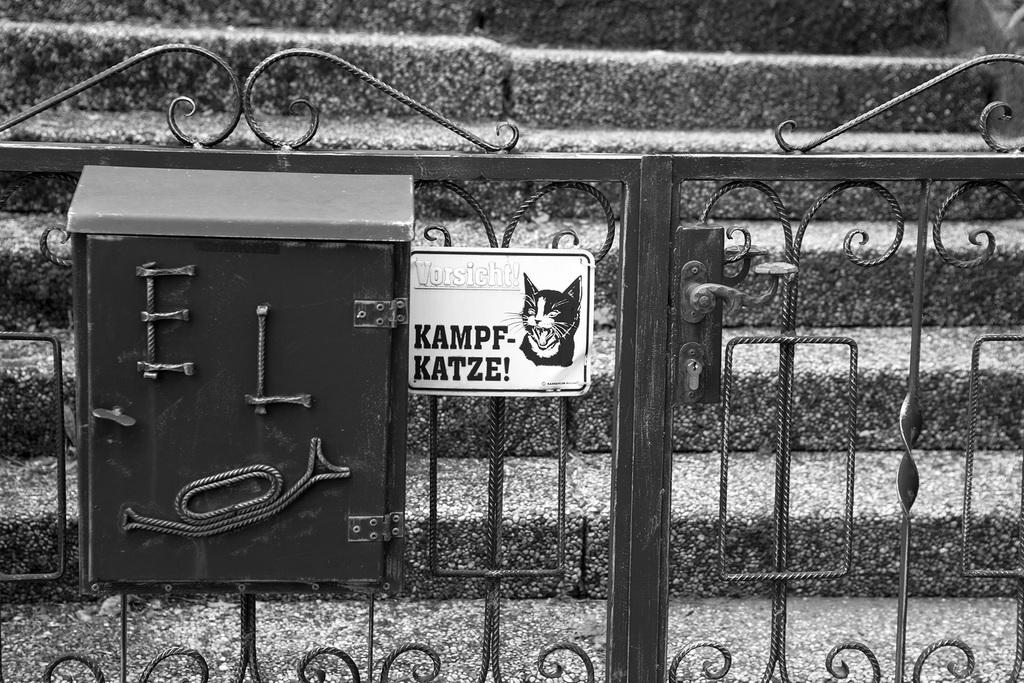What type of structure can be seen in the image? There is a metal gate in the image. Are there any additional objects attached to the gate? Yes, there is a box and a board attached to the gate. What is depicted on the board? The board has an image of a cat. Is there any text on the board? Yes, the board has some text. What can be seen behind the gate? There are stairs behind the gate. Can you tell me what type of stamp is on the cat's paw in the image? There is no stamp visible on the cat's paw in the image, as the cat is an image on the board and not a real cat. What kind of insect is crawling on the text of the board? There are no insects present on the board in the image. 